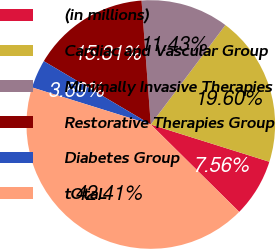<chart> <loc_0><loc_0><loc_500><loc_500><pie_chart><fcel>(in millions)<fcel>Cardiac and Vascular Group<fcel>Minimally Invasive Therapies<fcel>Restorative Therapies Group<fcel>Diabetes Group<fcel>tOtaL<nl><fcel>7.56%<fcel>19.6%<fcel>11.43%<fcel>15.31%<fcel>3.69%<fcel>42.41%<nl></chart> 